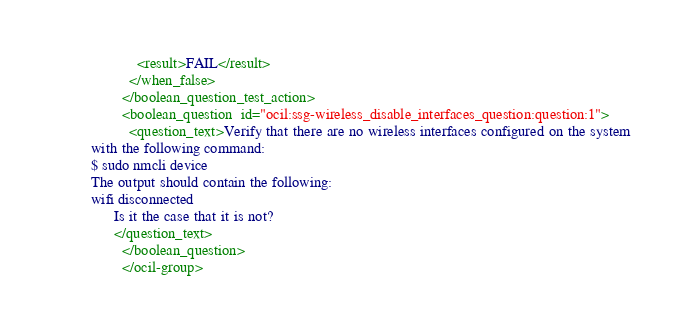Convert code to text. <code><loc_0><loc_0><loc_500><loc_500><_XML_>            <result>FAIL</result>
          </when_false>
        </boolean_question_test_action>
        <boolean_question  id="ocil:ssg-wireless_disable_interfaces_question:question:1">
          <question_text>Verify that there are no wireless interfaces configured on the system
with the following command:
$ sudo nmcli device
The output should contain the following:
wifi disconnected
      Is it the case that it is not?
      </question_text>
        </boolean_question>
        </ocil-group>
</code> 